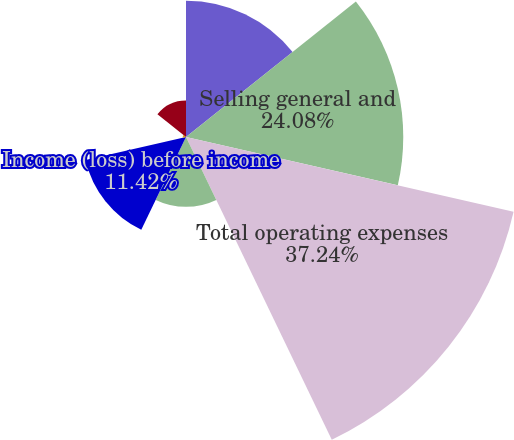Convert chart. <chart><loc_0><loc_0><loc_500><loc_500><pie_chart><fcel>Research and development<fcel>Selling general and<fcel>Total operating expenses<fcel>Income (loss) from operations<fcel>Income (loss) before income<fcel>Net income (loss)<fcel>Comprehensive income (loss)<nl><fcel>15.11%<fcel>24.08%<fcel>37.24%<fcel>7.74%<fcel>11.42%<fcel>0.36%<fcel>4.05%<nl></chart> 